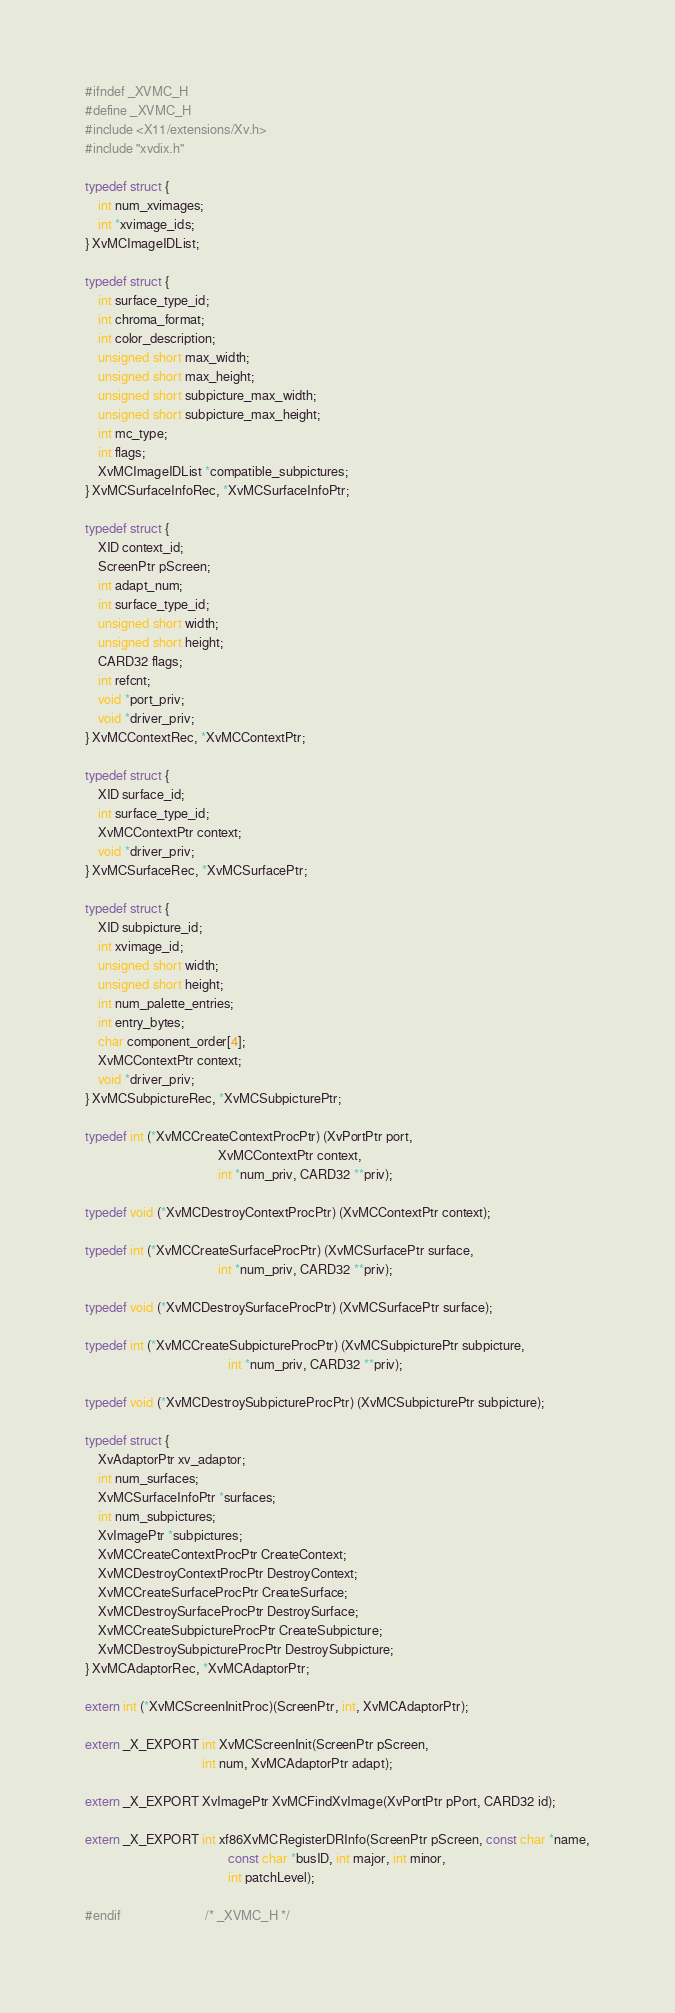<code> <loc_0><loc_0><loc_500><loc_500><_C_>
#ifndef _XVMC_H
#define _XVMC_H
#include <X11/extensions/Xv.h>
#include "xvdix.h"

typedef struct {
    int num_xvimages;
    int *xvimage_ids;
} XvMCImageIDList;

typedef struct {
    int surface_type_id;
    int chroma_format;
    int color_description;
    unsigned short max_width;
    unsigned short max_height;
    unsigned short subpicture_max_width;
    unsigned short subpicture_max_height;
    int mc_type;
    int flags;
    XvMCImageIDList *compatible_subpictures;
} XvMCSurfaceInfoRec, *XvMCSurfaceInfoPtr;

typedef struct {
    XID context_id;
    ScreenPtr pScreen;
    int adapt_num;
    int surface_type_id;
    unsigned short width;
    unsigned short height;
    CARD32 flags;
    int refcnt;
    void *port_priv;
    void *driver_priv;
} XvMCContextRec, *XvMCContextPtr;

typedef struct {
    XID surface_id;
    int surface_type_id;
    XvMCContextPtr context;
    void *driver_priv;
} XvMCSurfaceRec, *XvMCSurfacePtr;

typedef struct {
    XID subpicture_id;
    int xvimage_id;
    unsigned short width;
    unsigned short height;
    int num_palette_entries;
    int entry_bytes;
    char component_order[4];
    XvMCContextPtr context;
    void *driver_priv;
} XvMCSubpictureRec, *XvMCSubpicturePtr;

typedef int (*XvMCCreateContextProcPtr) (XvPortPtr port,
                                         XvMCContextPtr context,
                                         int *num_priv, CARD32 **priv);

typedef void (*XvMCDestroyContextProcPtr) (XvMCContextPtr context);

typedef int (*XvMCCreateSurfaceProcPtr) (XvMCSurfacePtr surface,
                                         int *num_priv, CARD32 **priv);

typedef void (*XvMCDestroySurfaceProcPtr) (XvMCSurfacePtr surface);

typedef int (*XvMCCreateSubpictureProcPtr) (XvMCSubpicturePtr subpicture,
                                            int *num_priv, CARD32 **priv);

typedef void (*XvMCDestroySubpictureProcPtr) (XvMCSubpicturePtr subpicture);

typedef struct {
    XvAdaptorPtr xv_adaptor;
    int num_surfaces;
    XvMCSurfaceInfoPtr *surfaces;
    int num_subpictures;
    XvImagePtr *subpictures;
    XvMCCreateContextProcPtr CreateContext;
    XvMCDestroyContextProcPtr DestroyContext;
    XvMCCreateSurfaceProcPtr CreateSurface;
    XvMCDestroySurfaceProcPtr DestroySurface;
    XvMCCreateSubpictureProcPtr CreateSubpicture;
    XvMCDestroySubpictureProcPtr DestroySubpicture;
} XvMCAdaptorRec, *XvMCAdaptorPtr;

extern int (*XvMCScreenInitProc)(ScreenPtr, int, XvMCAdaptorPtr);

extern _X_EXPORT int XvMCScreenInit(ScreenPtr pScreen,
                                    int num, XvMCAdaptorPtr adapt);

extern _X_EXPORT XvImagePtr XvMCFindXvImage(XvPortPtr pPort, CARD32 id);

extern _X_EXPORT int xf86XvMCRegisterDRInfo(ScreenPtr pScreen, const char *name,
                                            const char *busID, int major, int minor,
                                            int patchLevel);

#endif                          /* _XVMC_H */
</code> 